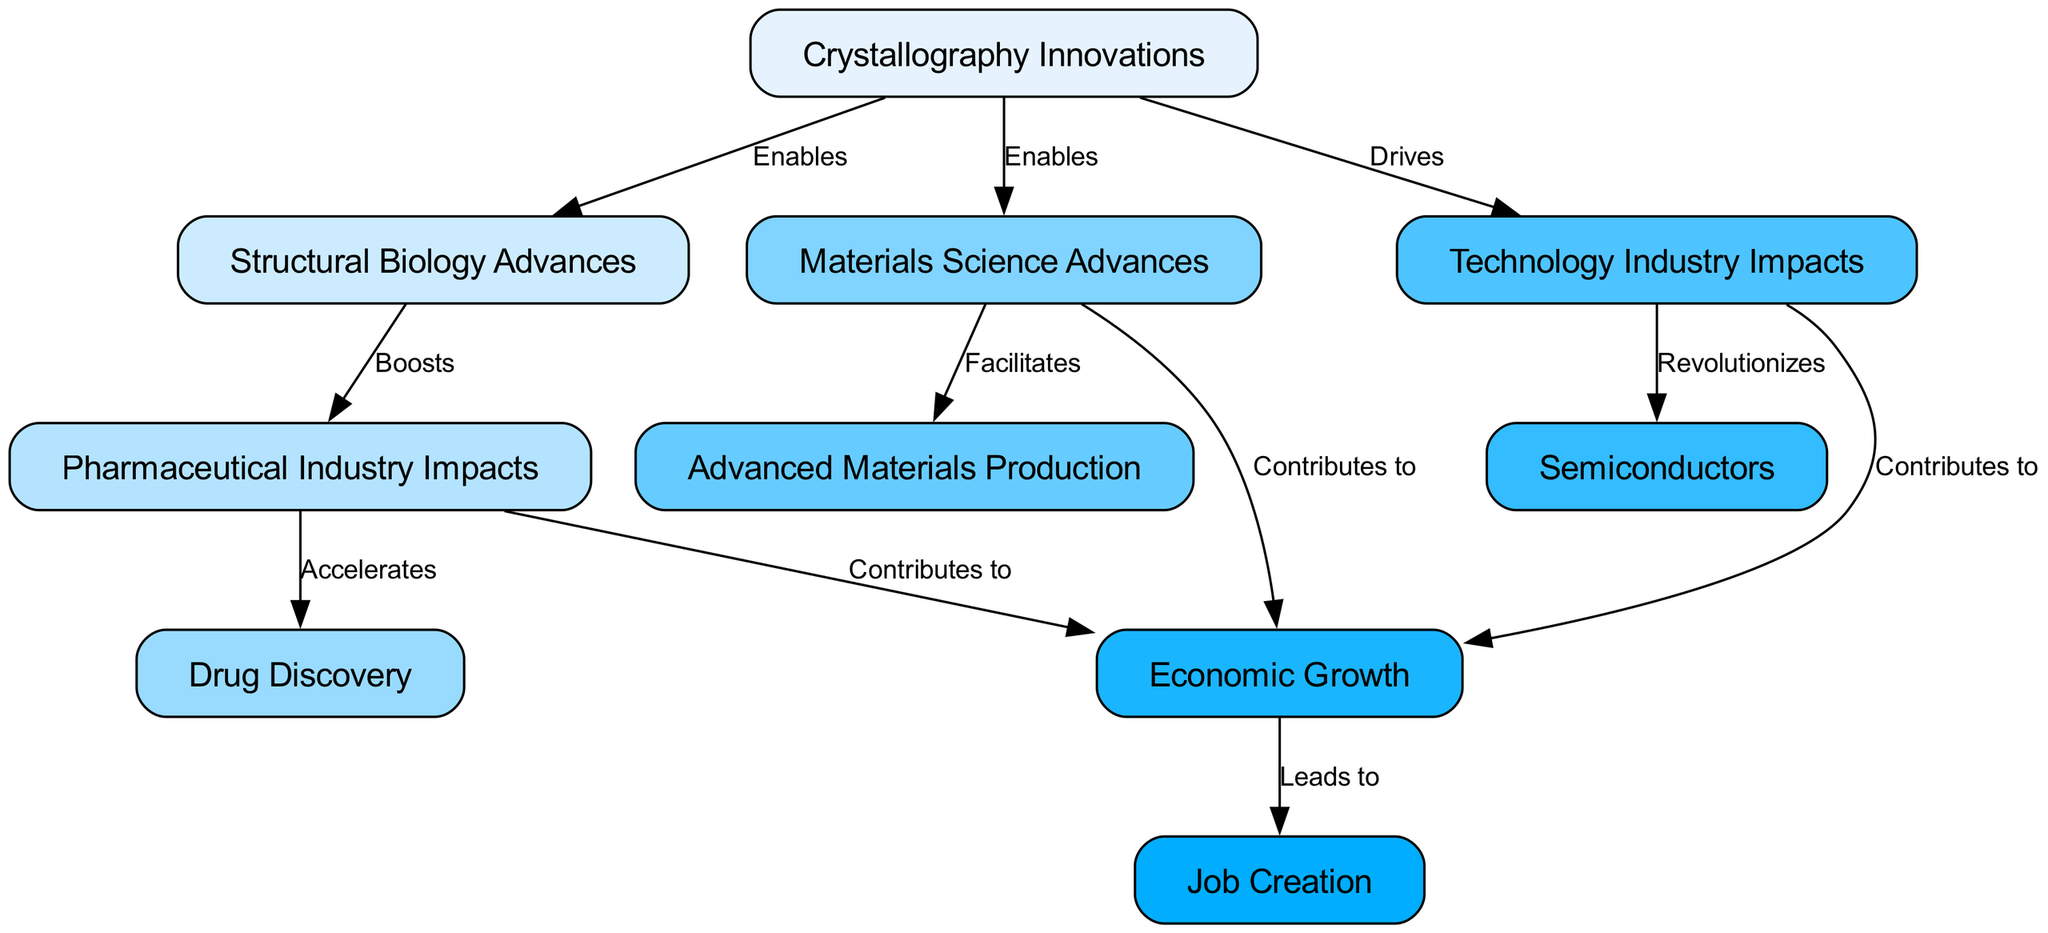What is the node that represents the initial concept in the diagram? The first node listed in the diagram is "Crystallography Innovations," signifying the foundation from which all other advancements and impacts stem.
Answer: Crystallography Innovations How many nodes are present in the diagram? By counting the individual elements provided for "nodes," we see there are a total of 10 unique nodes included in the diagram.
Answer: 10 Which industry does the node "Drug Discovery" directly impact? Tracing the edges from "pharmaceutical industry impacts," we find that "Drug Discovery" is a direct result of those impacts, illustrating its crucial role in this context.
Answer: Pharmaceutical Industry Impacts What does the edge from "technology industry impacts" to "semiconductors" signify? The edge labeled "Revolutionizes" indicates that advancements in technology significantly alter or improve the semiconductor industry, highlighting the relationship between the two.
Answer: Revolutionizes What is the final outcome node that emerges from "economic growth"? The diagram shows that "job creation" is a direct result of "economic growth," establishing a positive outcome from the growth spurred by various industries influenced by crystallography.
Answer: Job Creation How do "pharmaceutical industry impacts" contribute to the economy? The connection labeled "Contributes to" between "pharmaceutical industry impacts" and "economic growth" indicates that advancements in the pharmaceutical sector play a vital role in enhancing economic health.
Answer: Contributes to What type of advances are driven by "crystallography innovations" in materials science? The diagram explicitly states that "materials science advances" are enabled by "crystallography innovations", demonstrating a link between the two fields.
Answer: Enables How many total impacts lead to "economic growth"? By summing the contributions from "pharmaceutical industry impacts," "materials science advances," and "technology industry impacts," we confirm there are three distinct paths leading to "economic growth."
Answer: 3 What role do "structural biology advances" play in the pharmaceutical industry? The edge marked "Boosts" indicates that "structural biology advances" enhance or improve the conditions in the pharmaceutical sector, highlighting its supportive role.
Answer: Boosts 